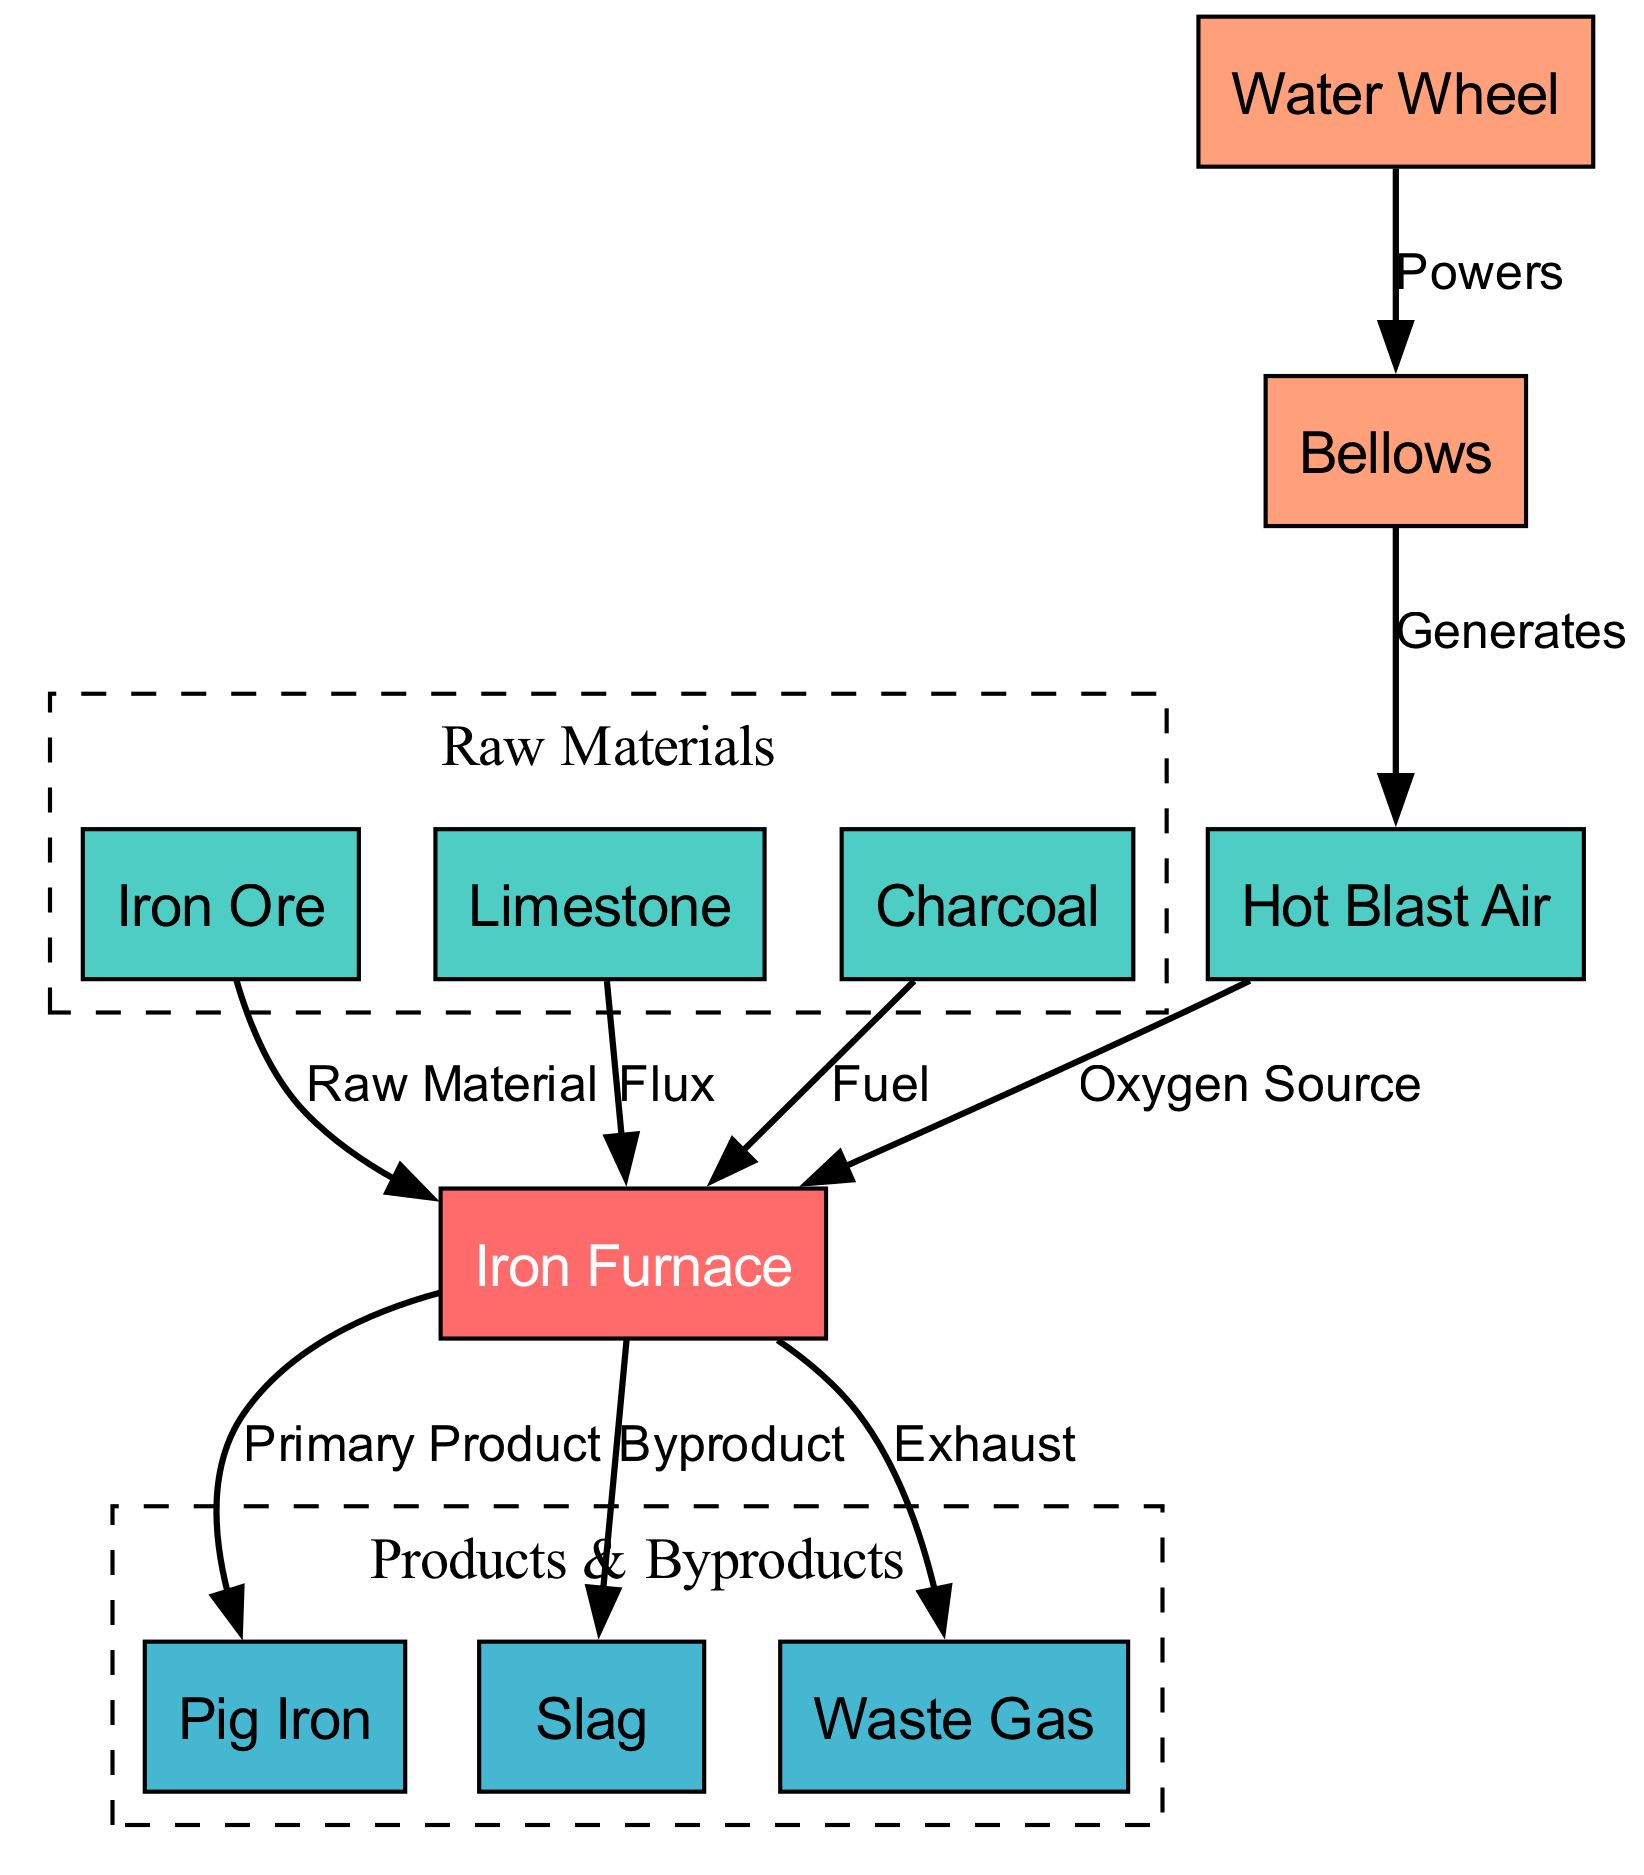What is the primary product of the furnace? The diagram indicates that the primary output from the furnace is pig iron, which is directly connected to the furnace node with an edge labeled "Primary Product."
Answer: Pig Iron What are the raw materials input to the furnace? The diagram shows three nodes feeding into the furnace: iron ore, limestone, and charcoal, which are labeled as "Raw Material," "Flux," and "Fuel" respectively.
Answer: Iron Ore, Limestone, Charcoal How many edges are present in the diagram? By counting the connections between nodes, it can be seen that there are a total of eight edges connecting various inputs and outputs to the furnace.
Answer: Eight Which component generates the hot blast air? The diagram shows that the bellows are responsible for generating the hot blast air, indicated by the directed edge from bellows to blast air labeled "Generates."
Answer: Bellows What byproduct is produced alongside pig iron? The diagram indicates that slag is produced as a byproduct of the iron furnace operation, with a direct edge labeled "Byproduct" from the furnace to slag.
Answer: Slag How is the bellows powered in the operation? The diagram illustrates that the water wheel powers the bellows, as shown by the edge between the water wheel and the bellows labeled "Powers."
Answer: Water Wheel What is the role of limestone in the furnace operation? Limestone is indicated as the flux in the operation, which is a critical additive that helps in the smelting process, feeding directly into the furnace as noted in the edge from limestone to furnace labeled "Flux."
Answer: Flux What is the exhaust produced from the furnace? The diagram specifies that the waste gas is the exhaust generated by the furnace, with a direct edge labeled "Exhaust" leading away from the furnace to waste gas.
Answer: Waste Gas How does the furnace receive the oxygen source? The hot blast air serves as the oxygen source, which is supplied to the furnace via an edge labeled "Oxygen Source," connecting blast air to the furnace node.
Answer: Hot Blast Air 